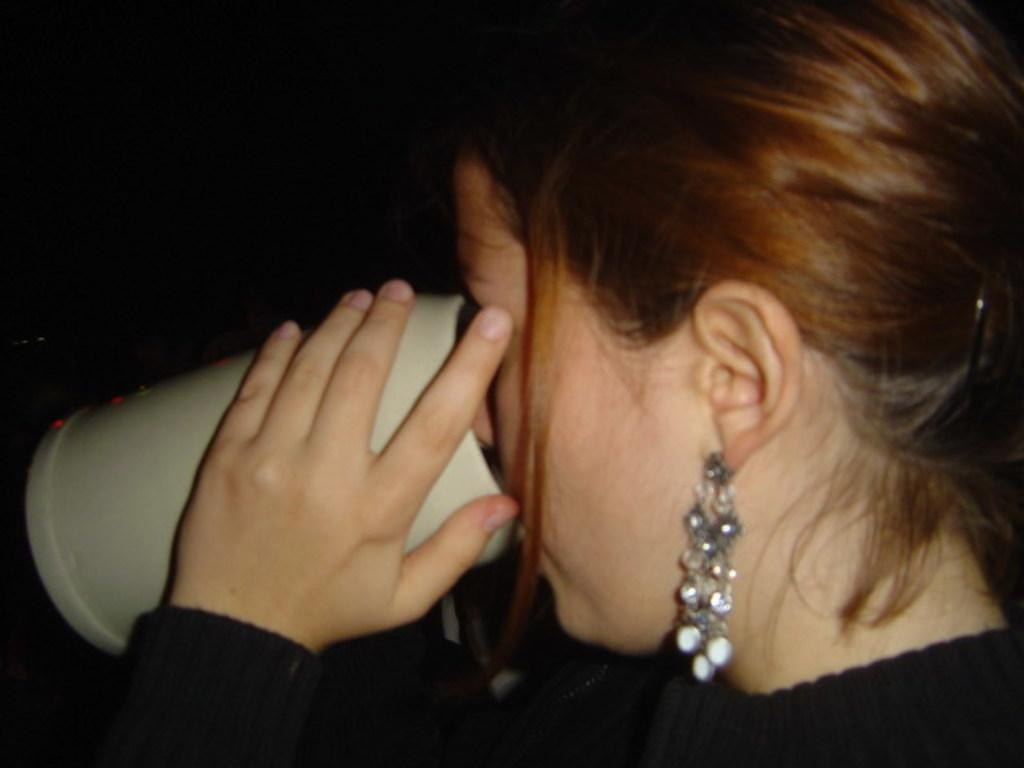Who is the main subject in the image? There is a woman in the image. What is the woman wearing? The woman is wearing a black dress. Are there any accessories visible on the woman? Yes, the woman is wearing earrings. What is the woman holding in the image? The woman is holding a cup. What is the woman doing with the cup? The woman is drinking from the cup. How would you describe the background of the image? The background of the image is dark. How many eggs are present in the image? There are no eggs visible in the image. What type of authority does the woman have in the image? The image does not provide any information about the woman's authority or position. 